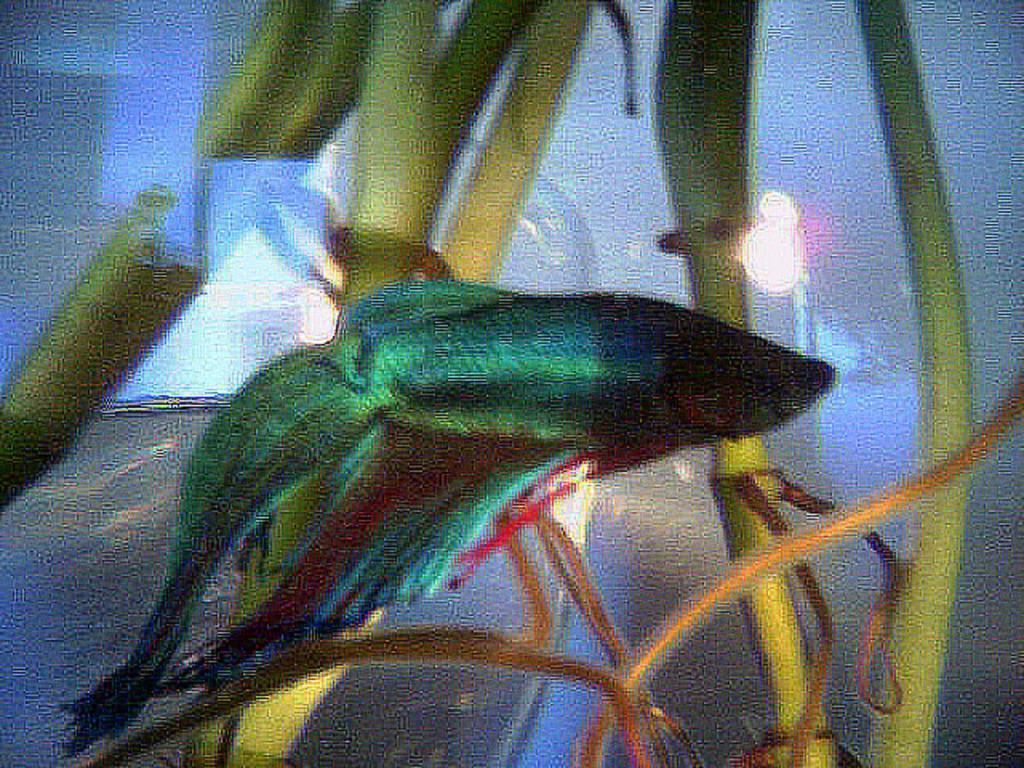Describe this image in one or two sentences. In this image there is an aquarium. In the middle of the image there is a fish and a few plants in the aquarium. 